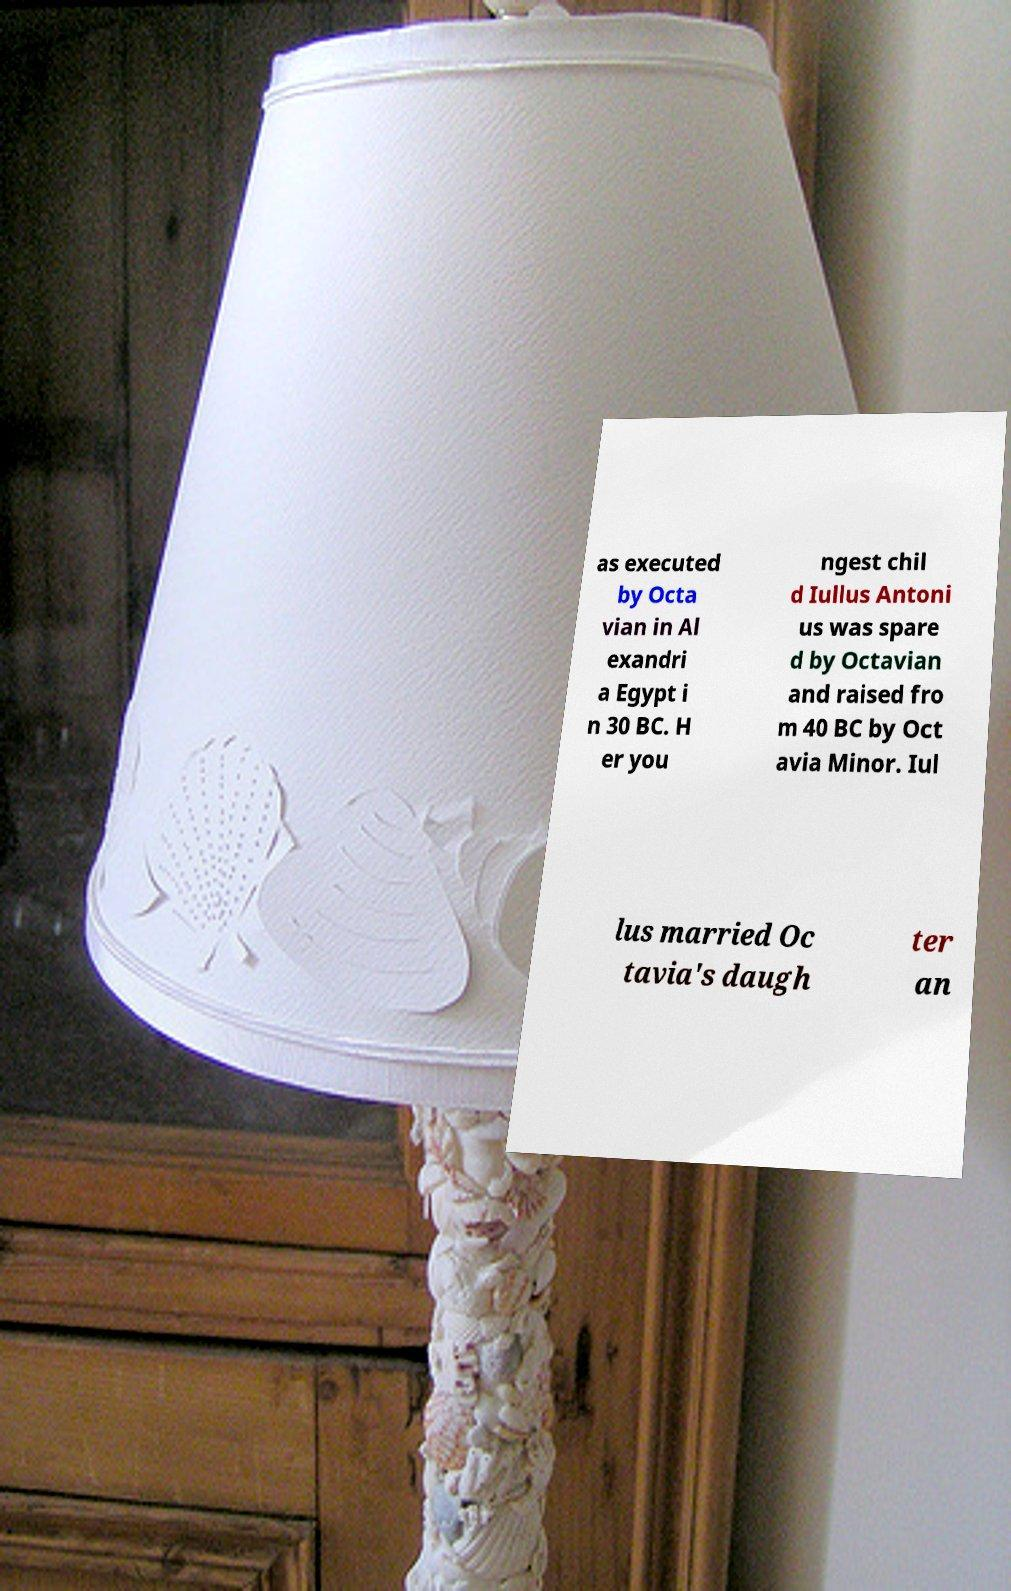Can you accurately transcribe the text from the provided image for me? as executed by Octa vian in Al exandri a Egypt i n 30 BC. H er you ngest chil d Iullus Antoni us was spare d by Octavian and raised fro m 40 BC by Oct avia Minor. Iul lus married Oc tavia's daugh ter an 